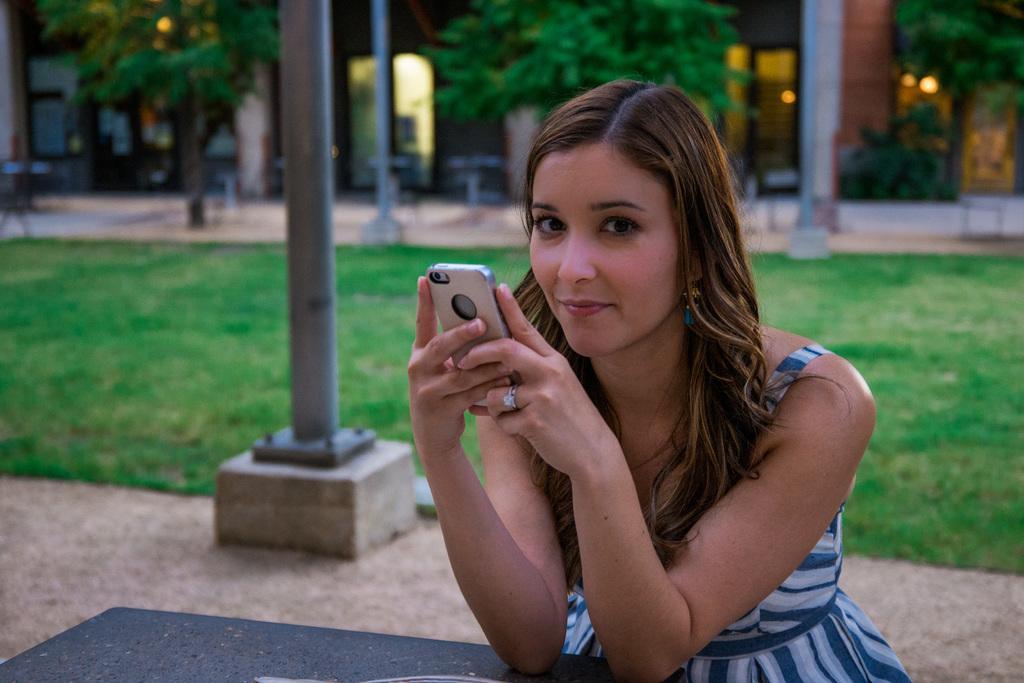Could you give a brief overview of what you see in this image? In this image woman is sitting and holding a mobile in her hand and is having smile on her face. In the background there are trees, poles. On the floor there is a grass and a building. 